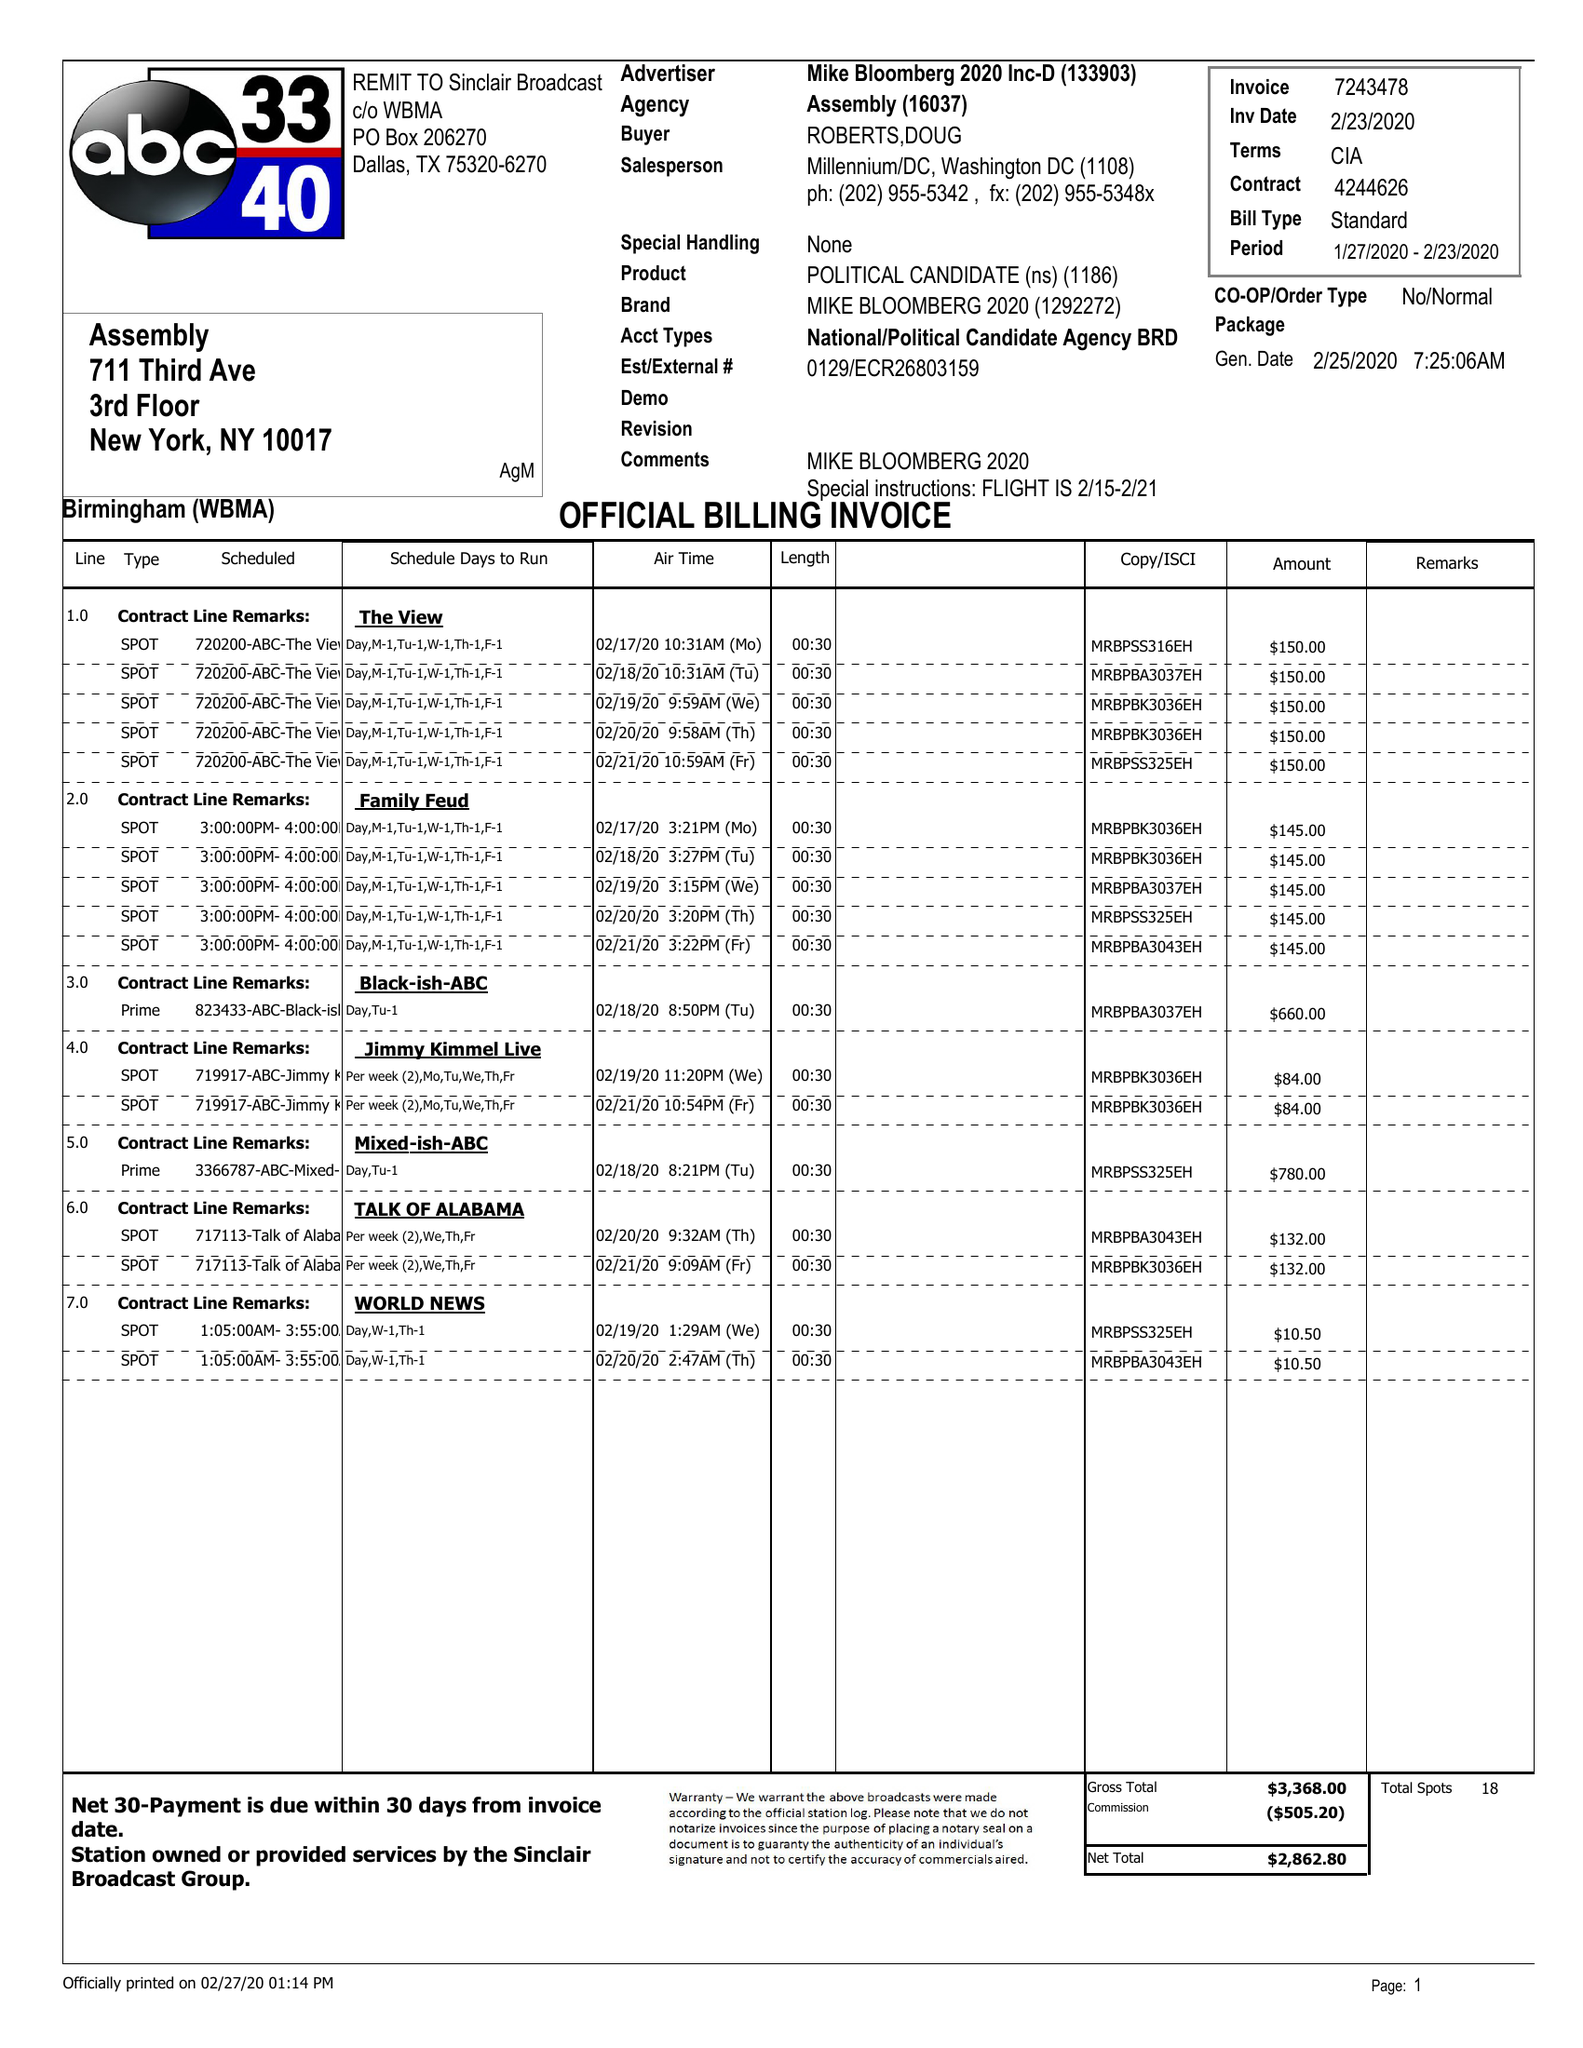What is the value for the advertiser?
Answer the question using a single word or phrase. MIKE BLOOMBERG 2020 INC-D 